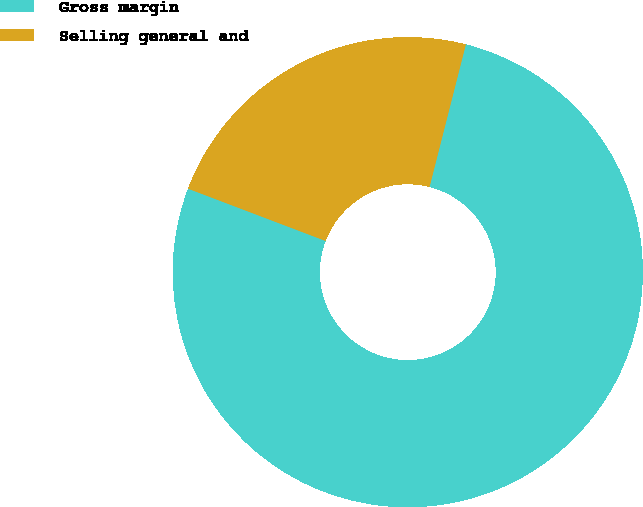Convert chart to OTSL. <chart><loc_0><loc_0><loc_500><loc_500><pie_chart><fcel>Gross margin<fcel>Selling general and<nl><fcel>76.81%<fcel>23.19%<nl></chart> 